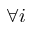Convert formula to latex. <formula><loc_0><loc_0><loc_500><loc_500>\forall i</formula> 